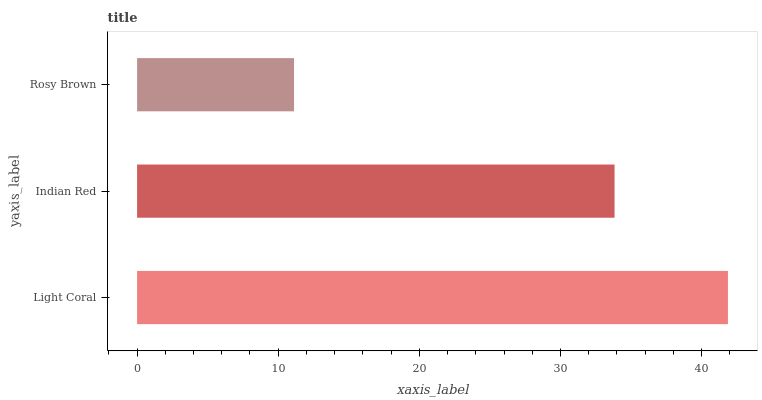Is Rosy Brown the minimum?
Answer yes or no. Yes. Is Light Coral the maximum?
Answer yes or no. Yes. Is Indian Red the minimum?
Answer yes or no. No. Is Indian Red the maximum?
Answer yes or no. No. Is Light Coral greater than Indian Red?
Answer yes or no. Yes. Is Indian Red less than Light Coral?
Answer yes or no. Yes. Is Indian Red greater than Light Coral?
Answer yes or no. No. Is Light Coral less than Indian Red?
Answer yes or no. No. Is Indian Red the high median?
Answer yes or no. Yes. Is Indian Red the low median?
Answer yes or no. Yes. Is Rosy Brown the high median?
Answer yes or no. No. Is Rosy Brown the low median?
Answer yes or no. No. 